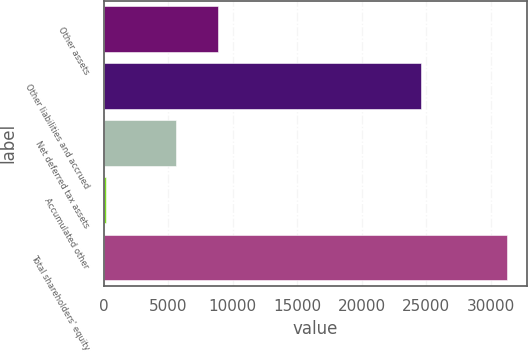Convert chart to OTSL. <chart><loc_0><loc_0><loc_500><loc_500><bar_chart><fcel>Other assets<fcel>Other liabilities and accrued<fcel>Net deferred tax assets<fcel>Accumulated other<fcel>Total shareholders' equity<nl><fcel>8851<fcel>24606<fcel>5593<fcel>199<fcel>31269<nl></chart> 